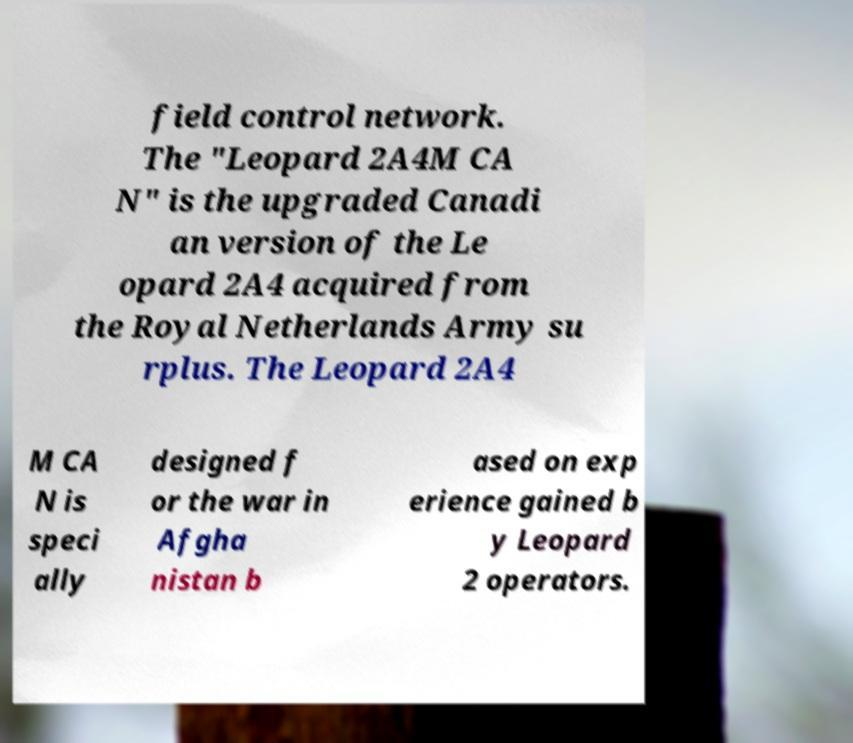Can you read and provide the text displayed in the image?This photo seems to have some interesting text. Can you extract and type it out for me? field control network. The "Leopard 2A4M CA N" is the upgraded Canadi an version of the Le opard 2A4 acquired from the Royal Netherlands Army su rplus. The Leopard 2A4 M CA N is speci ally designed f or the war in Afgha nistan b ased on exp erience gained b y Leopard 2 operators. 